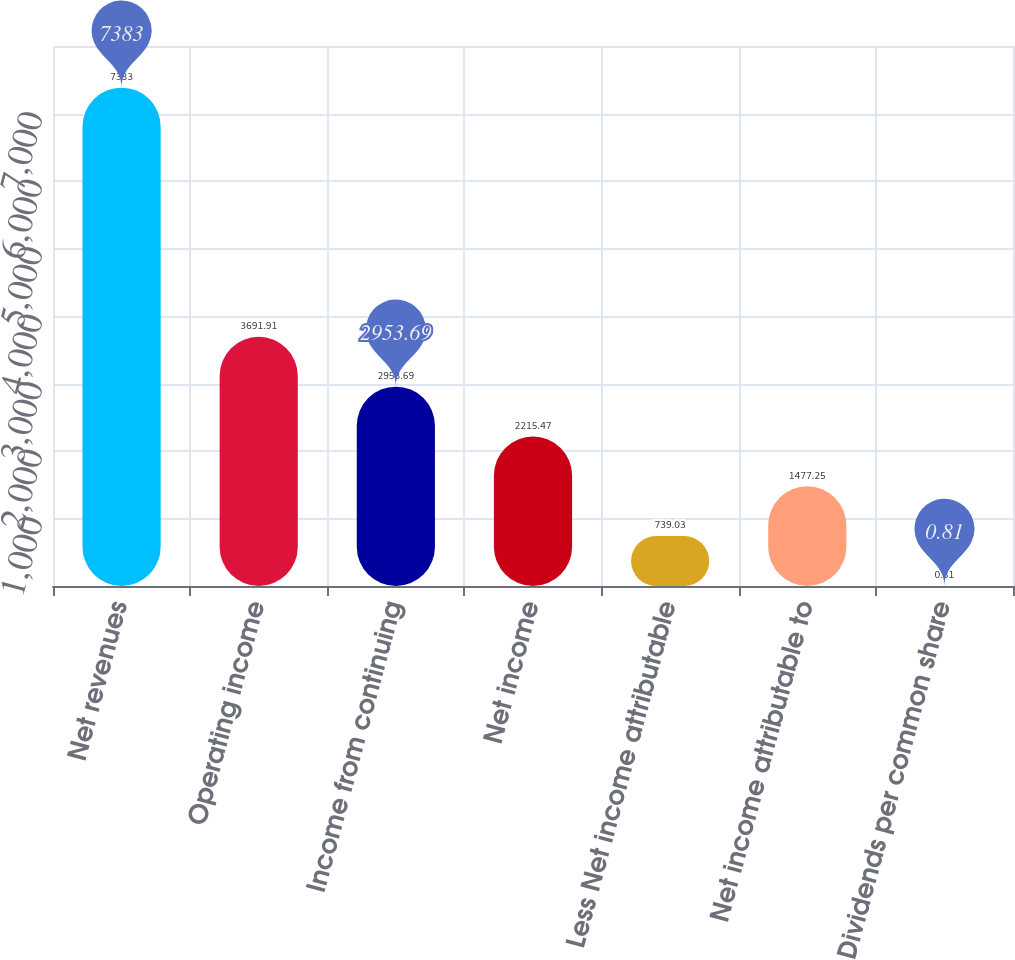Convert chart. <chart><loc_0><loc_0><loc_500><loc_500><bar_chart><fcel>Net revenues<fcel>Operating income<fcel>Income from continuing<fcel>Net income<fcel>Less Net income attributable<fcel>Net income attributable to<fcel>Dividends per common share<nl><fcel>7383<fcel>3691.91<fcel>2953.69<fcel>2215.47<fcel>739.03<fcel>1477.25<fcel>0.81<nl></chart> 